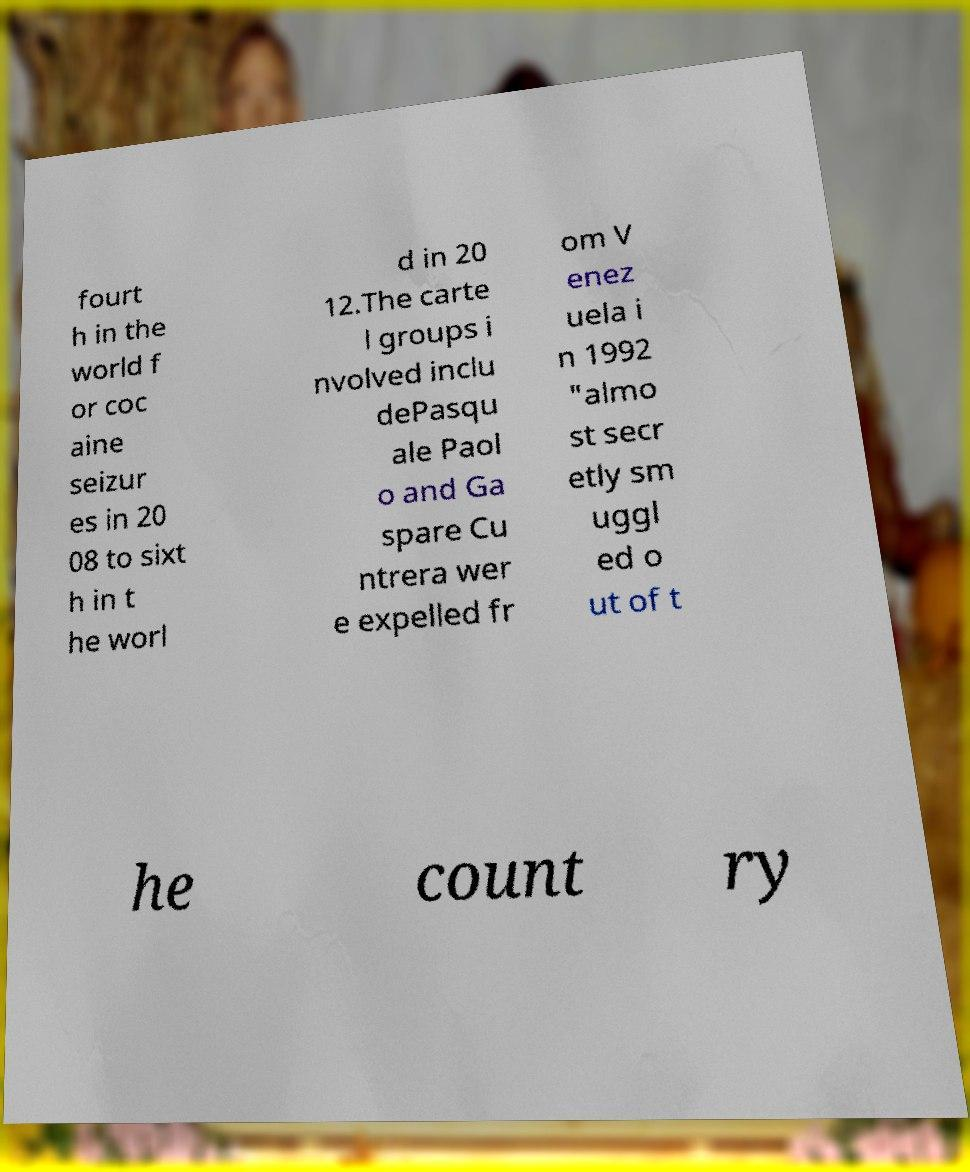I need the written content from this picture converted into text. Can you do that? fourt h in the world f or coc aine seizur es in 20 08 to sixt h in t he worl d in 20 12.The carte l groups i nvolved inclu dePasqu ale Paol o and Ga spare Cu ntrera wer e expelled fr om V enez uela i n 1992 "almo st secr etly sm uggl ed o ut of t he count ry 